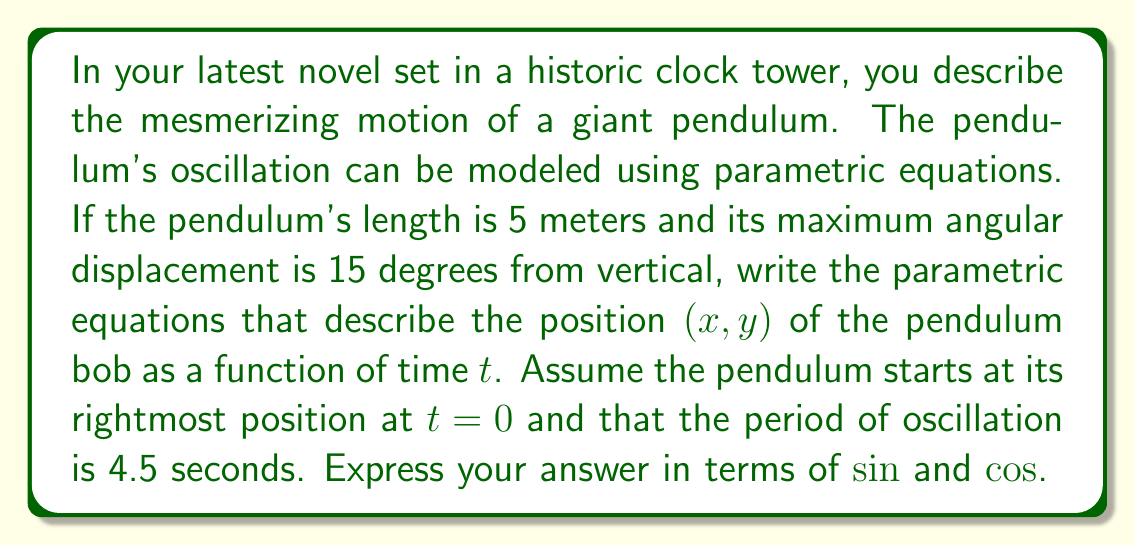Solve this math problem. To model the pendulum's motion, we'll follow these steps:

1) First, recall the general parametric equations for a simple pendulum:

   $$x = L \sin(\theta \cos(\omega t))$$
   $$y = -L \cos(\theta \cos(\omega t))$$

   Where $L$ is the pendulum length, $\theta$ is the maximum angular displacement, and $\omega$ is the angular frequency.

2) We're given $L = 5$ meters and $\theta = 15° = \frac{\pi}{12}$ radians.

3) To find $\omega$, we use the relationship between period $T$ and angular frequency:
   
   $$\omega = \frac{2\pi}{T} = \frac{2\pi}{4.5} = \frac{4\pi}{9}$$

4) Substituting these values into our general equations:

   $$x = 5 \sin(\frac{\pi}{12} \cos(\frac{4\pi}{9}t))$$
   $$y = -5 \cos(\frac{\pi}{12} \cos(\frac{4\pi}{9}t))$$

5) However, we need to adjust the equations because the pendulum starts at its rightmost position at $t=0$. This means we need to shift the cosine term by $\frac{\pi}{2}$:

   $$x = 5 \sin(\frac{\pi}{12} \cos(\frac{4\pi}{9}t - \frac{\pi}{2}))$$
   $$y = -5 \cos(\frac{\pi}{12} \cos(\frac{4\pi}{9}t - \frac{\pi}{2}))$$

These equations now correctly model the pendulum's motion as described in the novel.
Answer: $$x = 5 \sin(\frac{\pi}{12} \cos(\frac{4\pi}{9}t - \frac{\pi}{2}))$$
$$y = -5 \cos(\frac{\pi}{12} \cos(\frac{4\pi}{9}t - \frac{\pi}{2}))$$ 